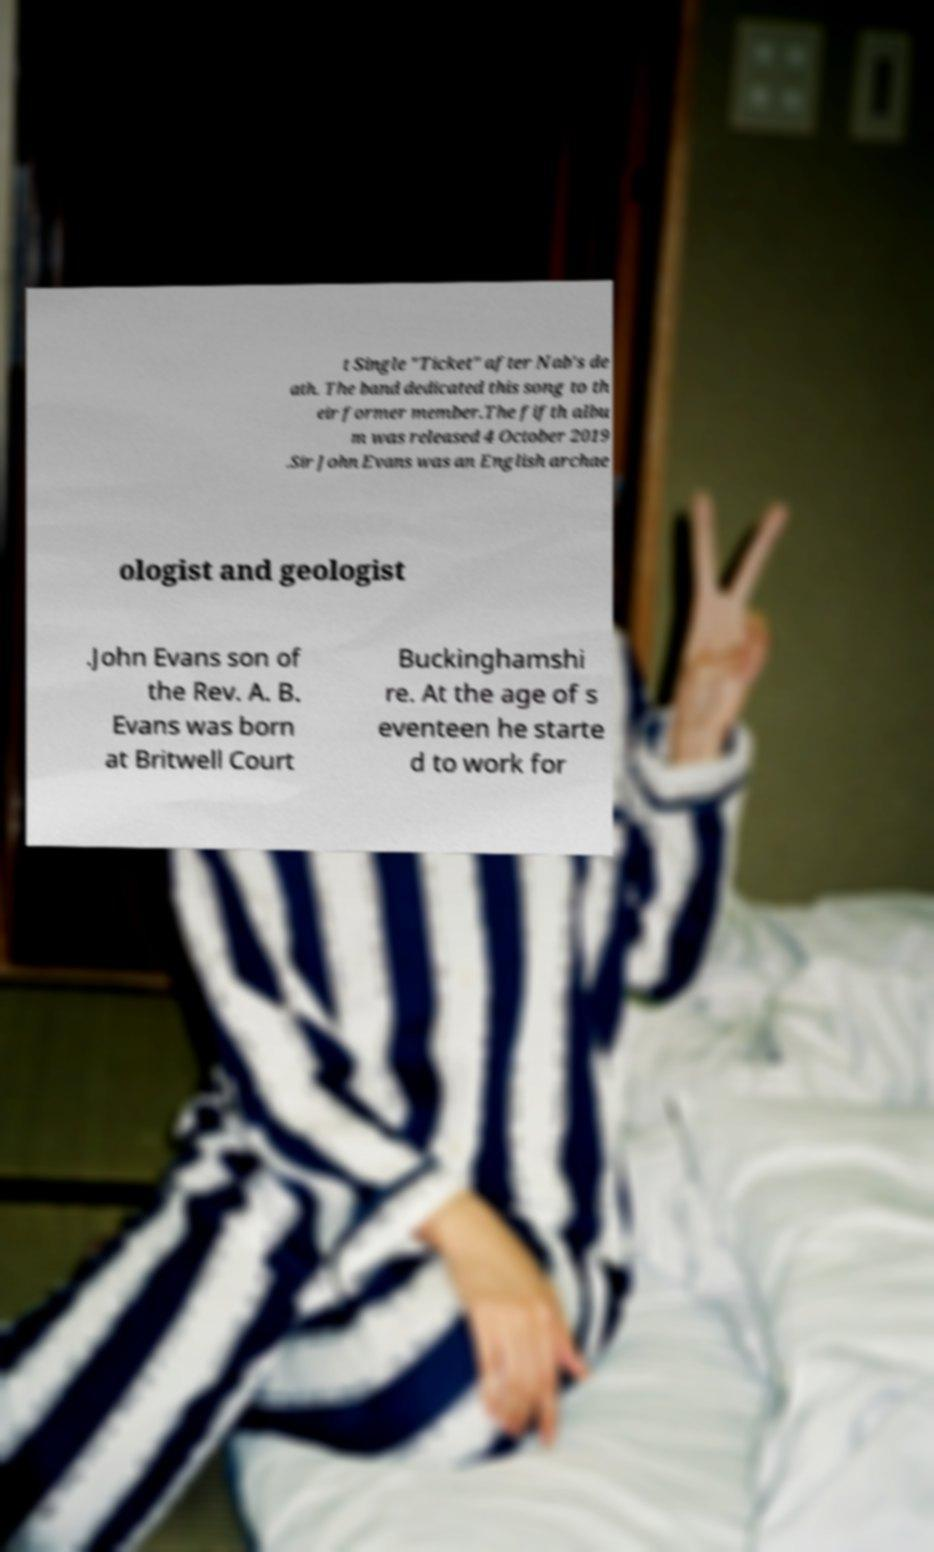Could you assist in decoding the text presented in this image and type it out clearly? t Single "Ticket" after Nab's de ath. The band dedicated this song to th eir former member.The fifth albu m was released 4 October 2019 .Sir John Evans was an English archae ologist and geologist .John Evans son of the Rev. A. B. Evans was born at Britwell Court Buckinghamshi re. At the age of s eventeen he starte d to work for 